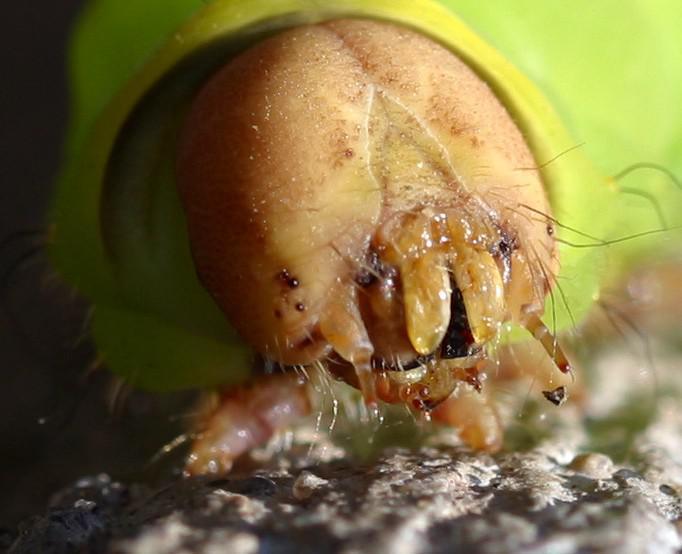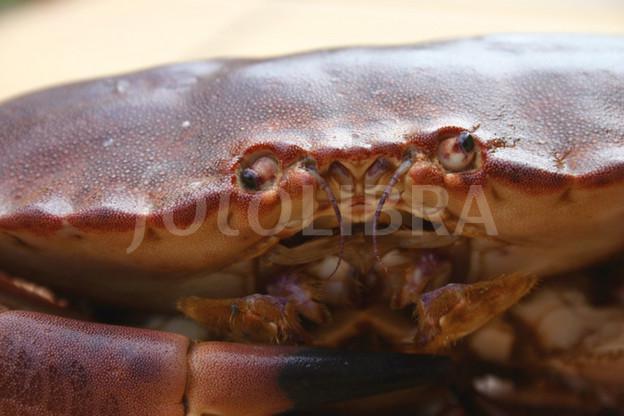The first image is the image on the left, the second image is the image on the right. Assess this claim about the two images: "One image shows the underside of a crab, and the other image shows a face-forward crab with eyes visible.". Correct or not? Answer yes or no. No. The first image is the image on the left, the second image is the image on the right. For the images displayed, is the sentence "In one of the images, the underbelly of a crab is shown." factually correct? Answer yes or no. No. 